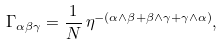Convert formula to latex. <formula><loc_0><loc_0><loc_500><loc_500>\Gamma _ { \alpha \beta \gamma } = \frac { 1 } { N } \, \eta ^ { - ( \alpha \wedge \beta + \beta \wedge \gamma + \gamma \wedge \alpha ) } ,</formula> 